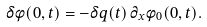<formula> <loc_0><loc_0><loc_500><loc_500>\delta \phi ( 0 , t ) = - \delta q ( t ) \, \partial _ { x } \phi _ { 0 } ( 0 , t ) .</formula> 